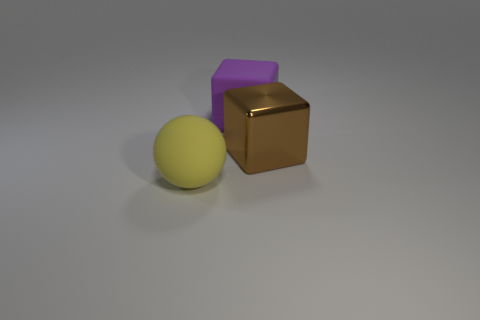Add 3 large green rubber balls. How many objects exist? 6 Subtract all blocks. How many objects are left? 1 Subtract 1 brown blocks. How many objects are left? 2 Subtract all big brown shiny cubes. Subtract all big blocks. How many objects are left? 0 Add 1 large spheres. How many large spheres are left? 2 Add 3 large cyan balls. How many large cyan balls exist? 3 